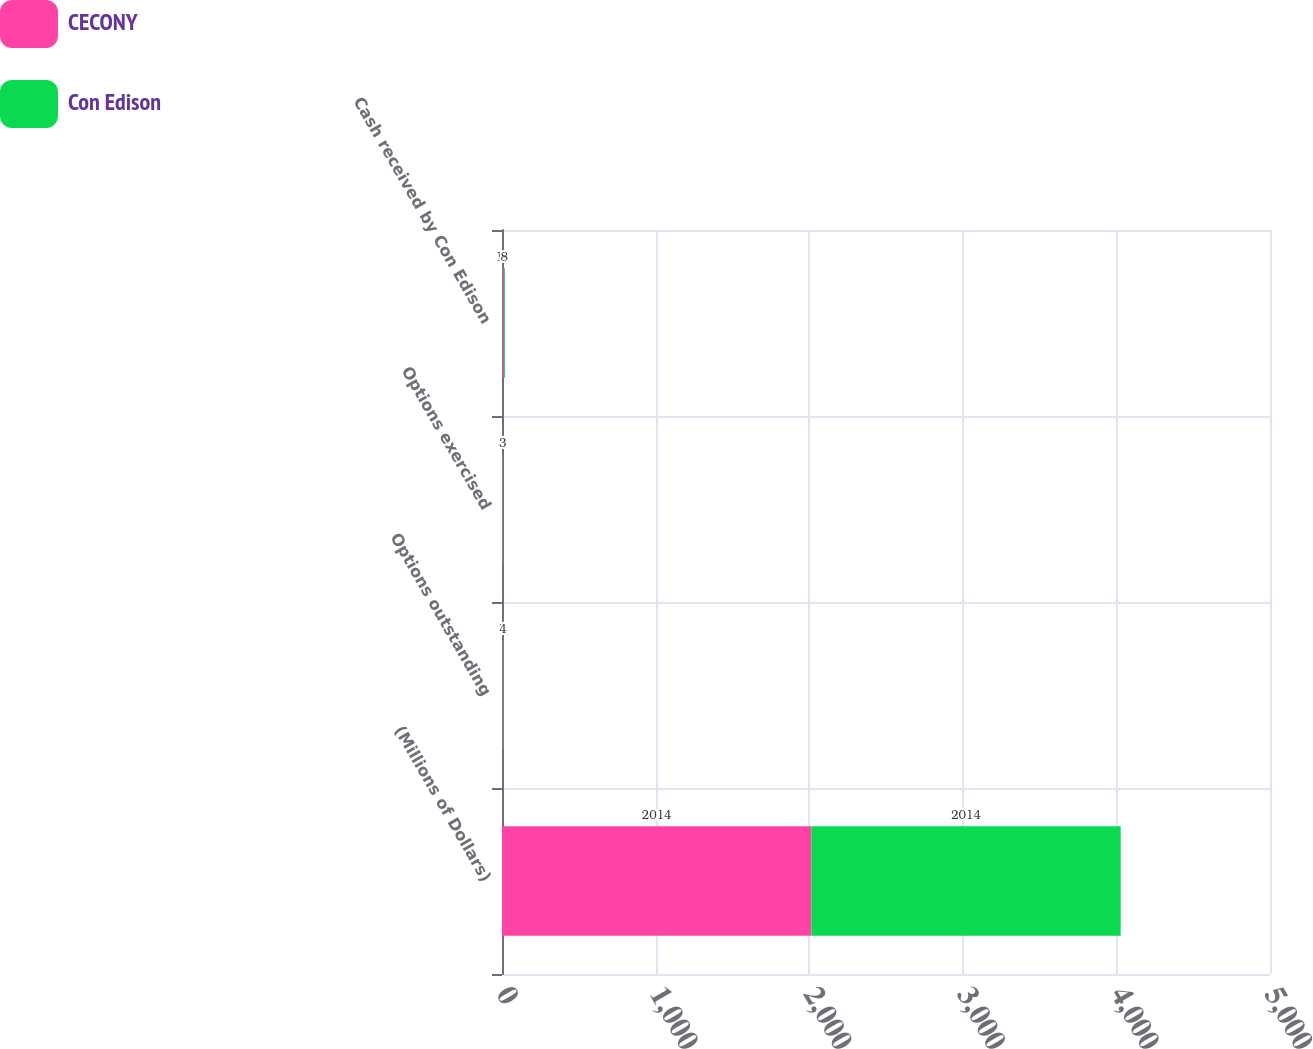Convert chart. <chart><loc_0><loc_0><loc_500><loc_500><stacked_bar_chart><ecel><fcel>(Millions of Dollars)<fcel>Options outstanding<fcel>Options exercised<fcel>Cash received by Con Edison<nl><fcel>CECONY<fcel>2014<fcel>5<fcel>4<fcel>11<nl><fcel>Con Edison<fcel>2014<fcel>4<fcel>3<fcel>8<nl></chart> 